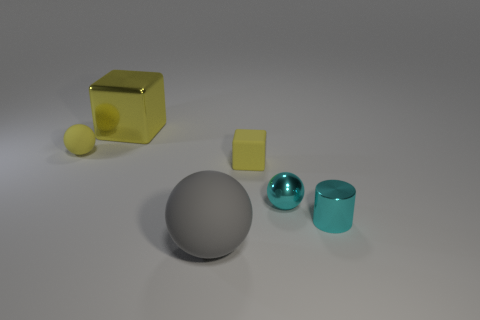Subtract all gray rubber balls. How many balls are left? 2 Add 1 small objects. How many objects exist? 7 Subtract all cyan balls. How many balls are left? 2 Subtract all blocks. How many objects are left? 4 Subtract all blue cylinders. Subtract all yellow blocks. How many cylinders are left? 1 Subtract all green cylinders. How many cyan blocks are left? 0 Subtract all small purple metallic balls. Subtract all small blocks. How many objects are left? 5 Add 3 tiny yellow cubes. How many tiny yellow cubes are left? 4 Add 2 big blue things. How many big blue things exist? 2 Subtract 0 blue cylinders. How many objects are left? 6 